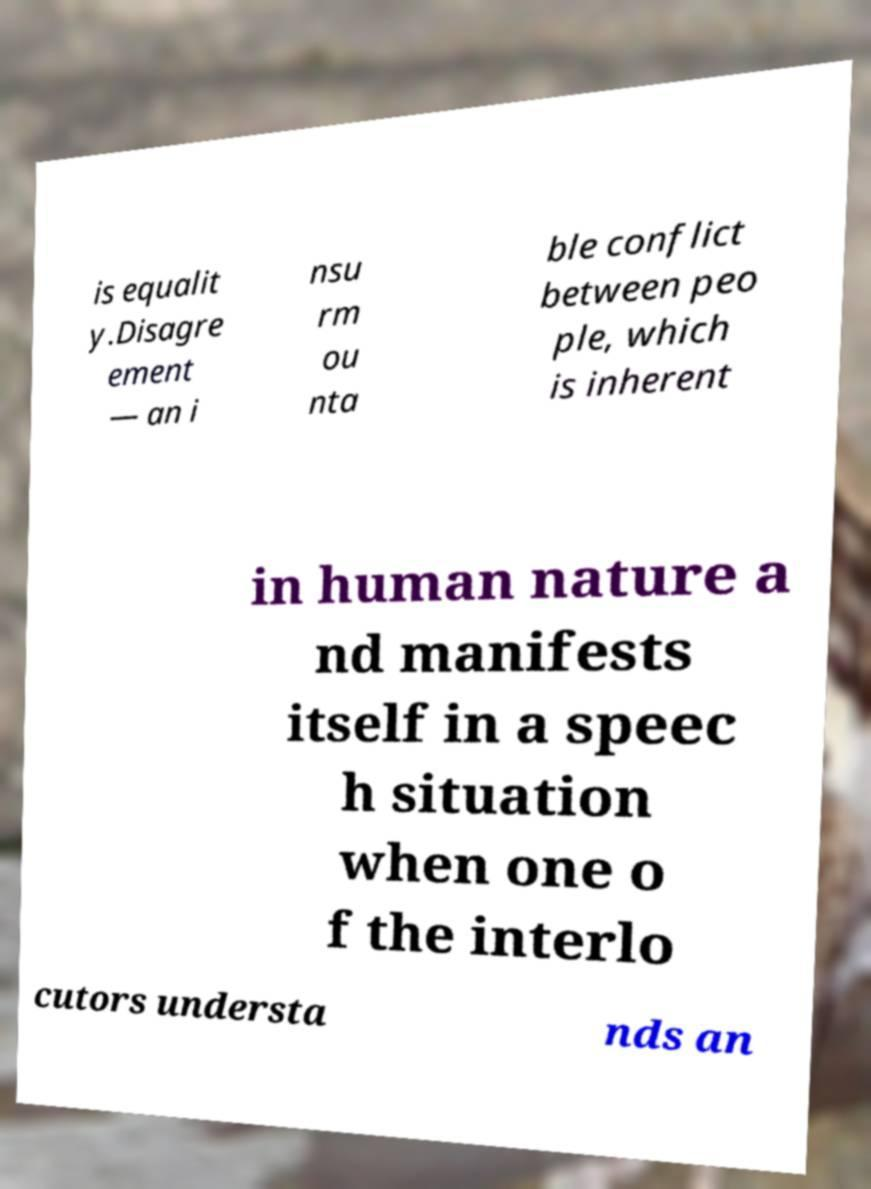Please identify and transcribe the text found in this image. is equalit y.Disagre ement — an i nsu rm ou nta ble conflict between peo ple, which is inherent in human nature a nd manifests itself in a speec h situation when one o f the interlo cutors understa nds an 